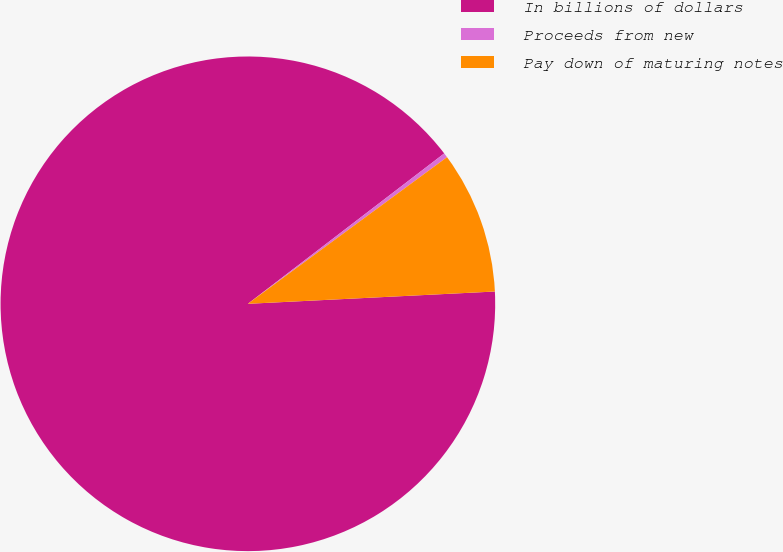<chart> <loc_0><loc_0><loc_500><loc_500><pie_chart><fcel>In billions of dollars<fcel>Proceeds from new<fcel>Pay down of maturing notes<nl><fcel>90.38%<fcel>0.3%<fcel>9.31%<nl></chart> 